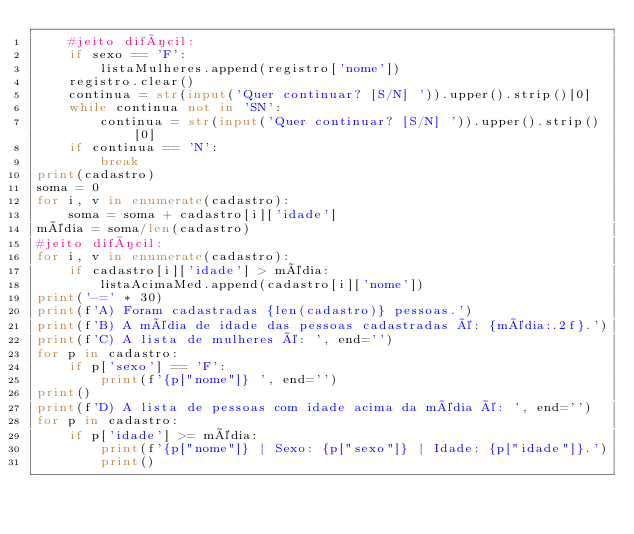Convert code to text. <code><loc_0><loc_0><loc_500><loc_500><_Python_>    #jeito difícil:
    if sexo == 'F':
        listaMulheres.append(registro['nome'])
    registro.clear()
    continua = str(input('Quer continuar? [S/N] ')).upper().strip()[0]
    while continua not in 'SN':
        continua = str(input('Quer continuar? [S/N] ')).upper().strip()[0]
    if continua == 'N':
        break
print(cadastro)
soma = 0
for i, v in enumerate(cadastro):
    soma = soma + cadastro[i]['idade']
média = soma/len(cadastro)
#jeito difícil:
for i, v in enumerate(cadastro):
    if cadastro[i]['idade'] > média:
        listaAcimaMed.append(cadastro[i]['nome'])
print('-=' * 30)
print(f'A) Foram cadastradas {len(cadastro)} pessoas.')
print(f'B) A média de idade das pessoas cadastradas é: {média:.2f}.')
print(f'C) A lista de mulheres é: ', end='')
for p in cadastro:
    if p['sexo'] == 'F':
        print(f'{p["nome"]} ', end='')
print()
print(f'D) A lista de pessoas com idade acima da média é: ', end='')
for p in cadastro:
    if p['idade'] >= média:
        print(f'{p["nome"]} | Sexo: {p["sexo"]} | Idade: {p["idade"]}.')
        print()
</code> 